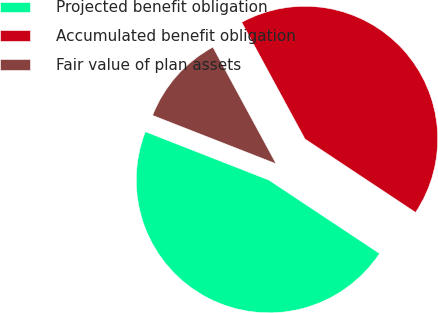<chart> <loc_0><loc_0><loc_500><loc_500><pie_chart><fcel>Projected benefit obligation<fcel>Accumulated benefit obligation<fcel>Fair value of plan assets<nl><fcel>46.62%<fcel>42.23%<fcel>11.15%<nl></chart> 